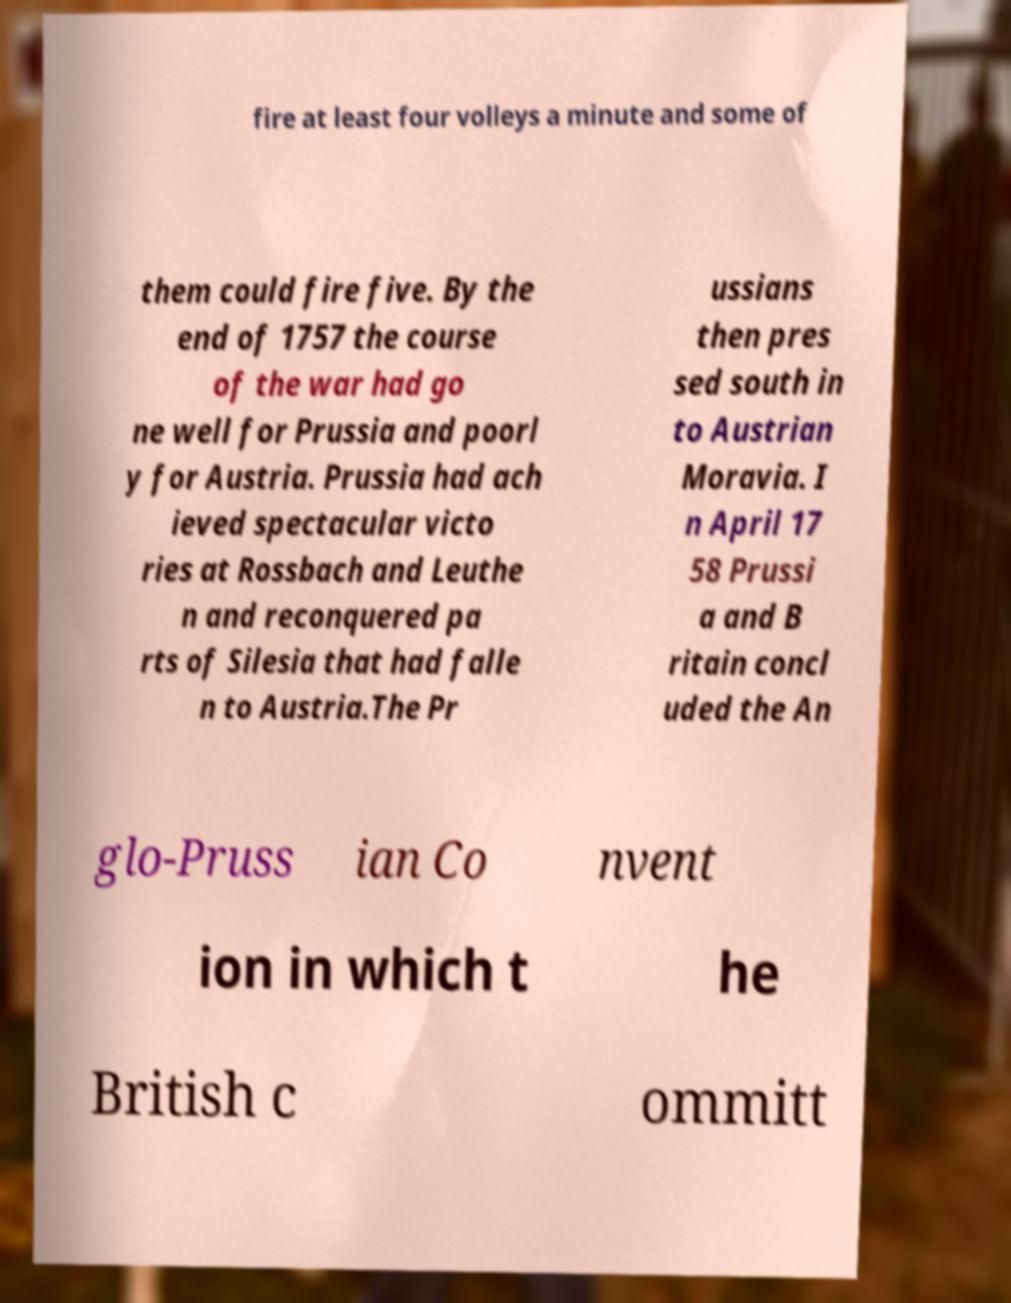Could you assist in decoding the text presented in this image and type it out clearly? fire at least four volleys a minute and some of them could fire five. By the end of 1757 the course of the war had go ne well for Prussia and poorl y for Austria. Prussia had ach ieved spectacular victo ries at Rossbach and Leuthe n and reconquered pa rts of Silesia that had falle n to Austria.The Pr ussians then pres sed south in to Austrian Moravia. I n April 17 58 Prussi a and B ritain concl uded the An glo-Pruss ian Co nvent ion in which t he British c ommitt 